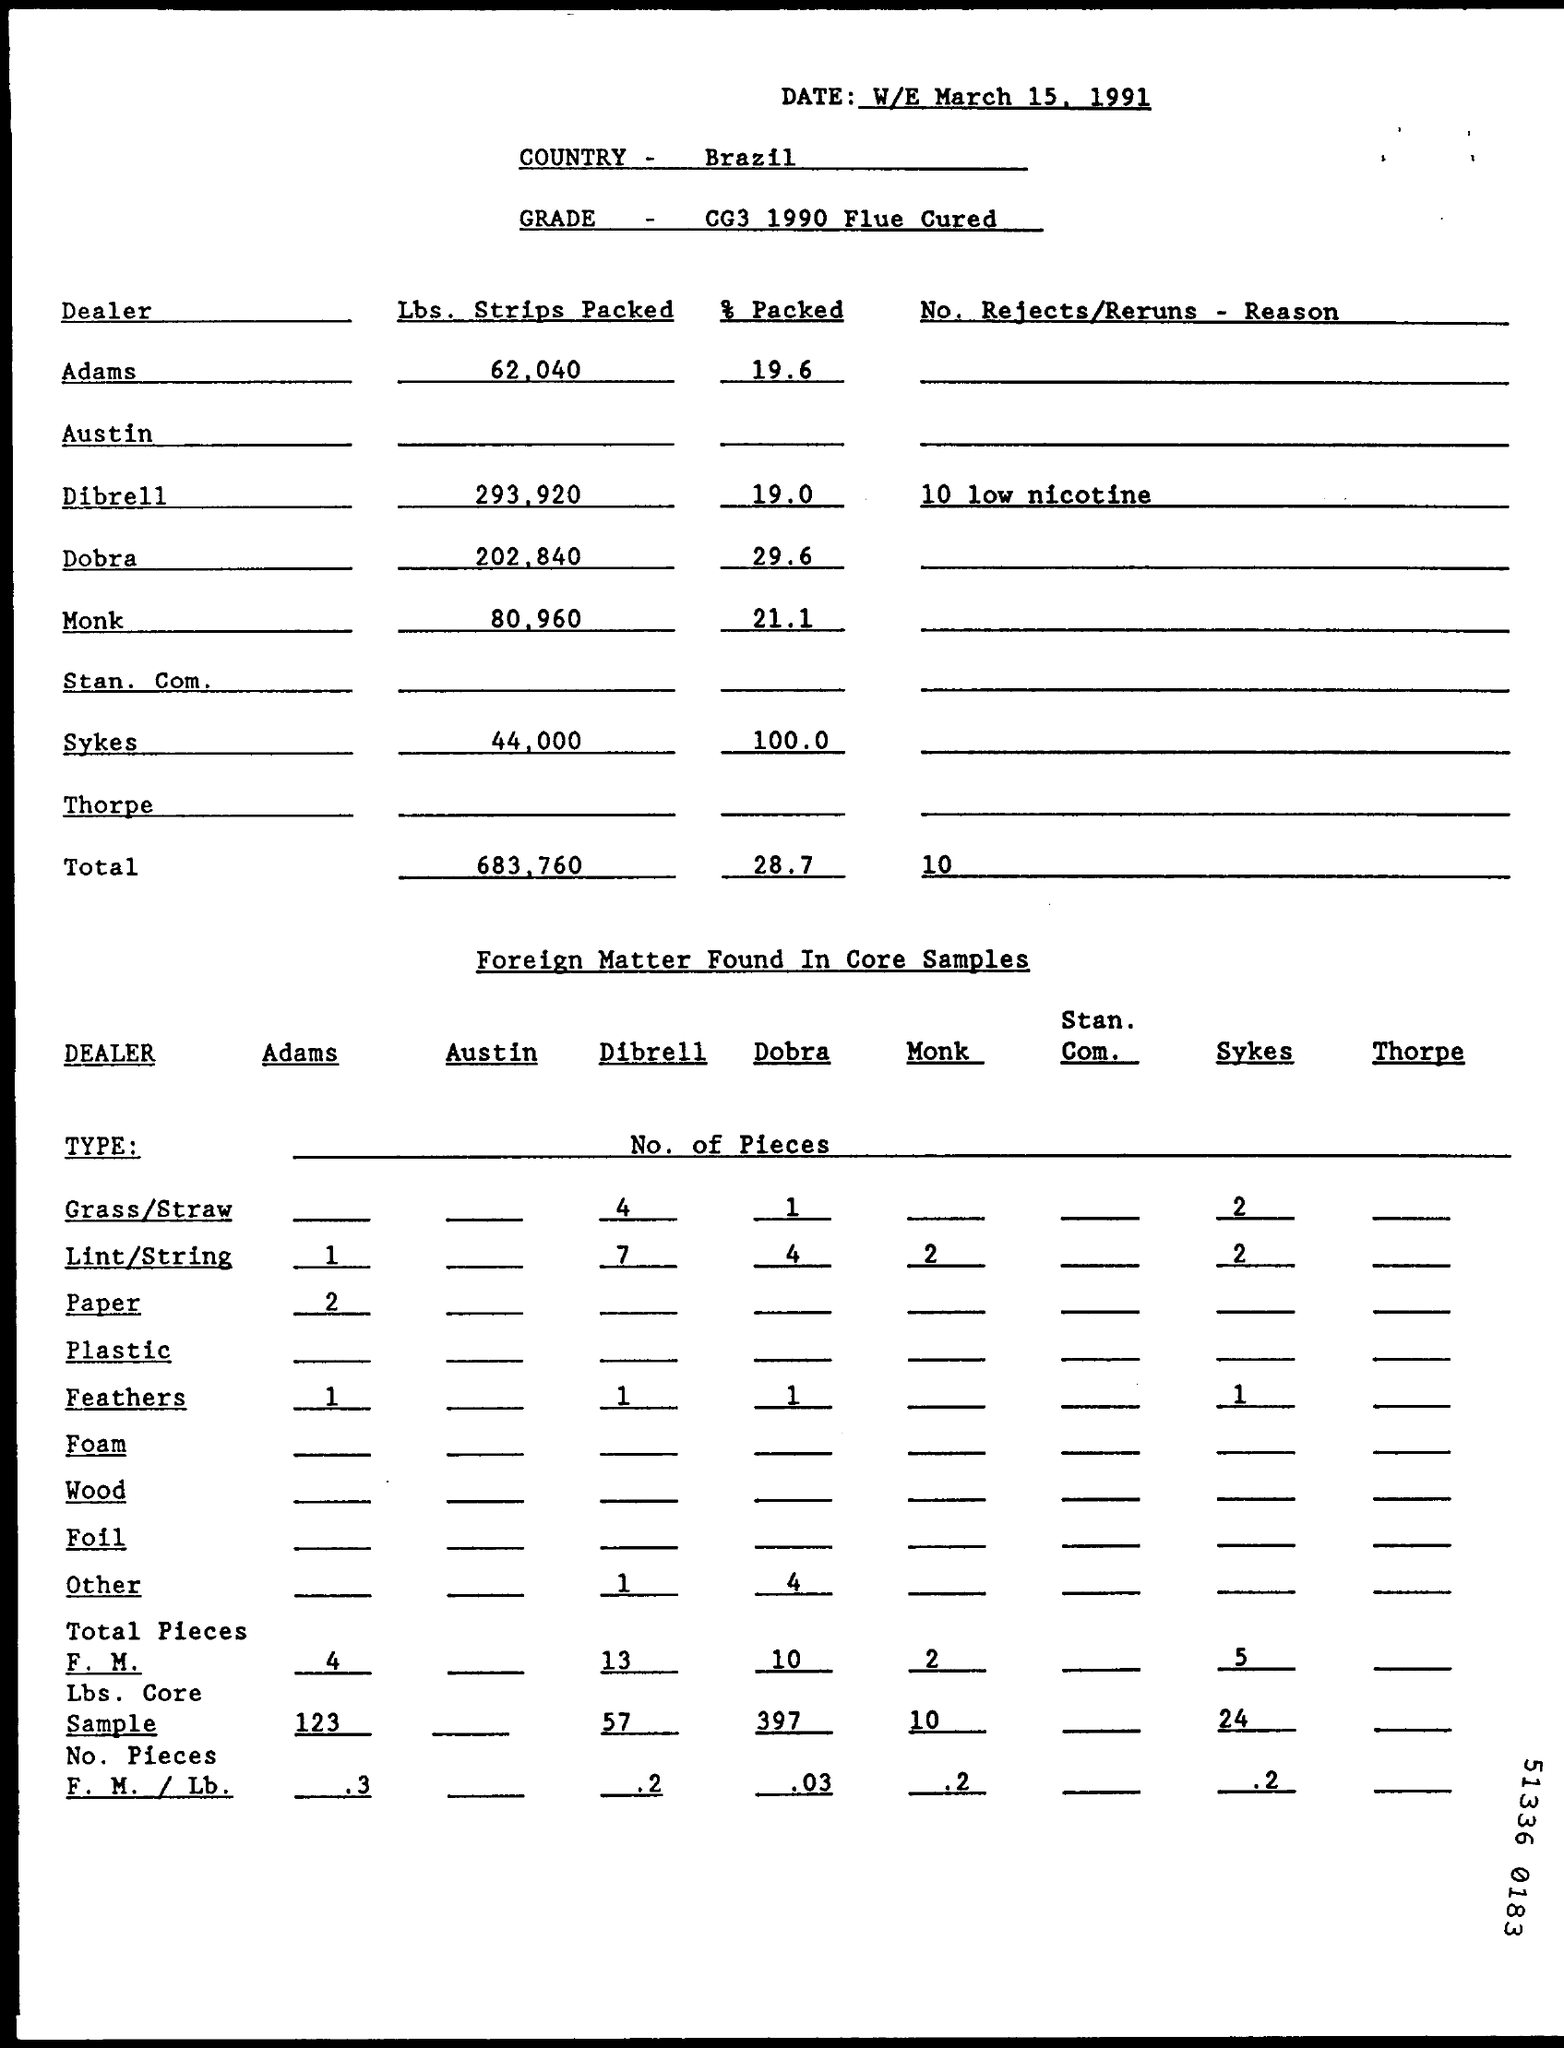What is written in GRADE Field ?
Your answer should be compact. CG3 1990 Flue Cured. What is the Total count of Rejects/Returns -Reason ?
Your answer should be very brief. 10. 